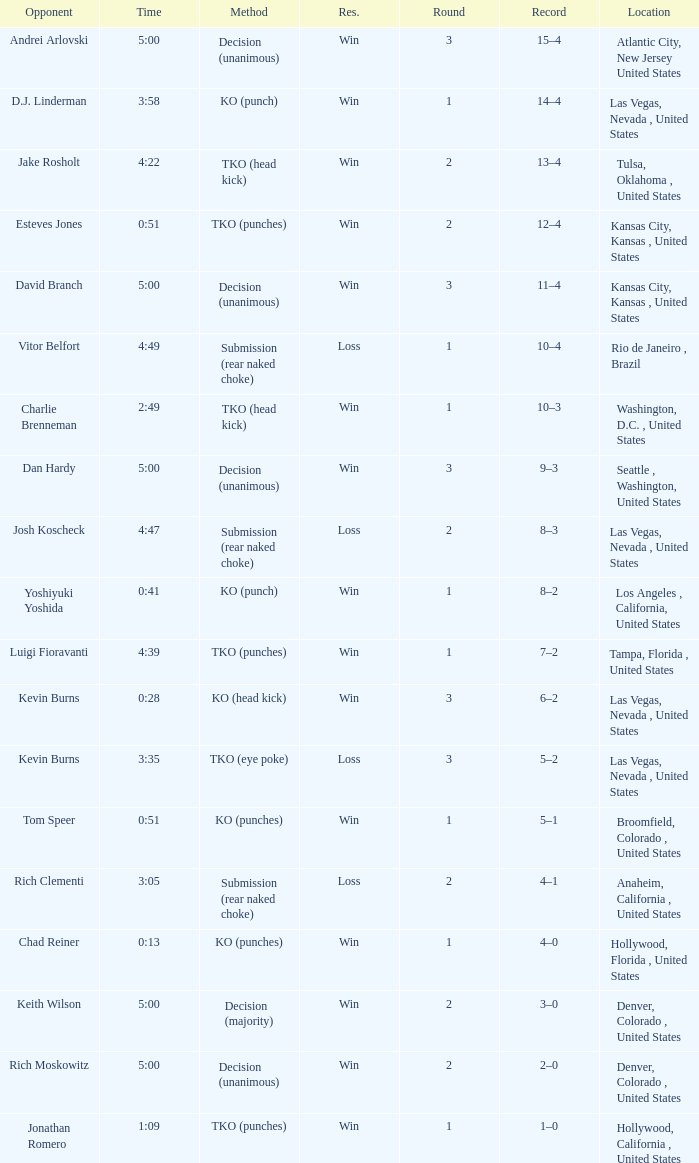What is the highest round number with a time of 4:39? 1.0. 